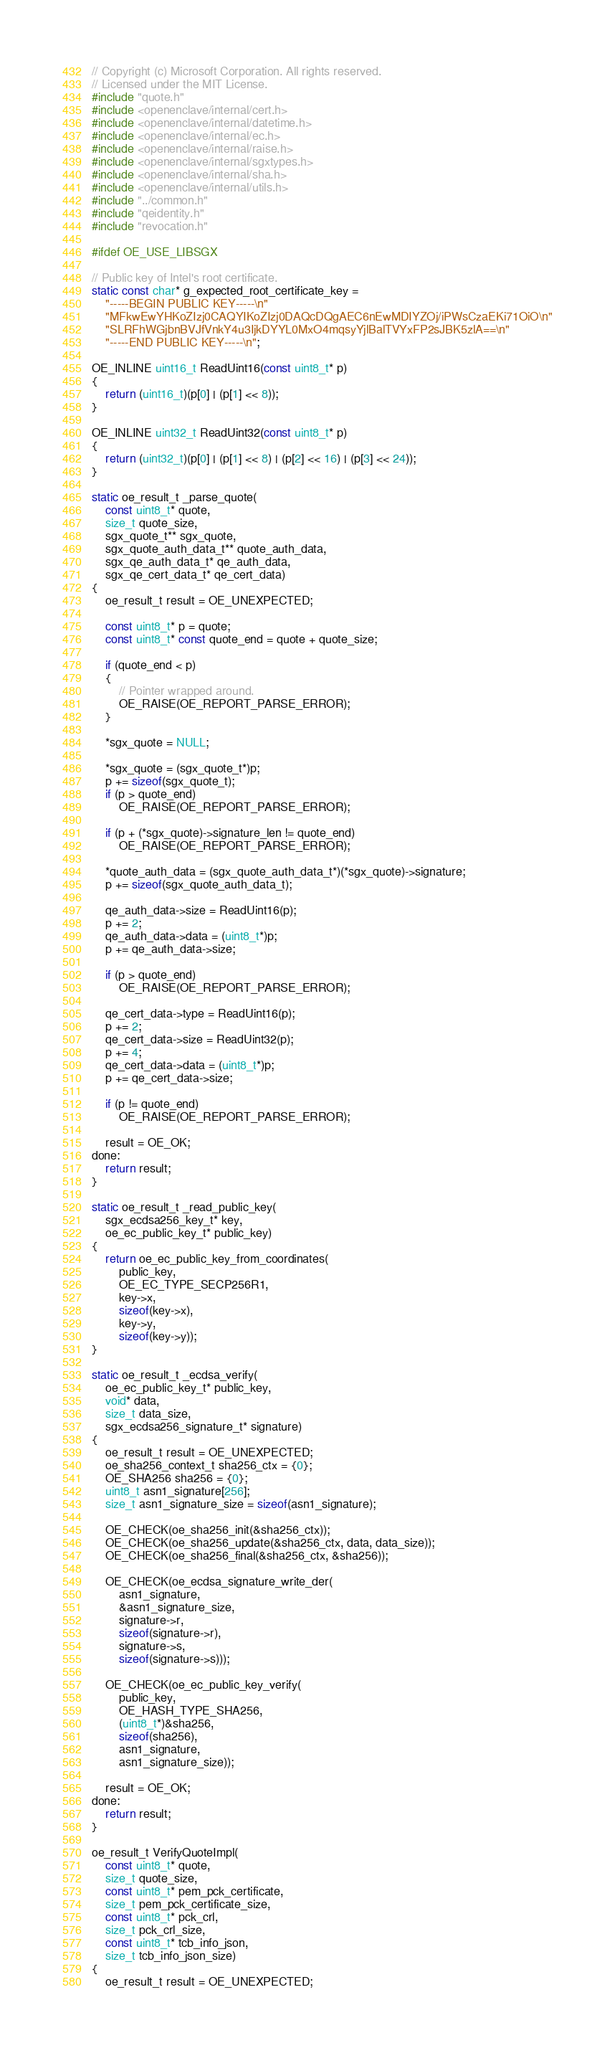<code> <loc_0><loc_0><loc_500><loc_500><_C_>// Copyright (c) Microsoft Corporation. All rights reserved.
// Licensed under the MIT License.
#include "quote.h"
#include <openenclave/internal/cert.h>
#include <openenclave/internal/datetime.h>
#include <openenclave/internal/ec.h>
#include <openenclave/internal/raise.h>
#include <openenclave/internal/sgxtypes.h>
#include <openenclave/internal/sha.h>
#include <openenclave/internal/utils.h>
#include "../common.h"
#include "qeidentity.h"
#include "revocation.h"

#ifdef OE_USE_LIBSGX

// Public key of Intel's root certificate.
static const char* g_expected_root_certificate_key =
    "-----BEGIN PUBLIC KEY-----\n"
    "MFkwEwYHKoZIzj0CAQYIKoZIzj0DAQcDQgAEC6nEwMDIYZOj/iPWsCzaEKi71OiO\n"
    "SLRFhWGjbnBVJfVnkY4u3IjkDYYL0MxO4mqsyYjlBalTVYxFP2sJBK5zlA==\n"
    "-----END PUBLIC KEY-----\n";

OE_INLINE uint16_t ReadUint16(const uint8_t* p)
{
    return (uint16_t)(p[0] | (p[1] << 8));
}

OE_INLINE uint32_t ReadUint32(const uint8_t* p)
{
    return (uint32_t)(p[0] | (p[1] << 8) | (p[2] << 16) | (p[3] << 24));
}

static oe_result_t _parse_quote(
    const uint8_t* quote,
    size_t quote_size,
    sgx_quote_t** sgx_quote,
    sgx_quote_auth_data_t** quote_auth_data,
    sgx_qe_auth_data_t* qe_auth_data,
    sgx_qe_cert_data_t* qe_cert_data)
{
    oe_result_t result = OE_UNEXPECTED;

    const uint8_t* p = quote;
    const uint8_t* const quote_end = quote + quote_size;

    if (quote_end < p)
    {
        // Pointer wrapped around.
        OE_RAISE(OE_REPORT_PARSE_ERROR);
    }

    *sgx_quote = NULL;

    *sgx_quote = (sgx_quote_t*)p;
    p += sizeof(sgx_quote_t);
    if (p > quote_end)
        OE_RAISE(OE_REPORT_PARSE_ERROR);

    if (p + (*sgx_quote)->signature_len != quote_end)
        OE_RAISE(OE_REPORT_PARSE_ERROR);

    *quote_auth_data = (sgx_quote_auth_data_t*)(*sgx_quote)->signature;
    p += sizeof(sgx_quote_auth_data_t);

    qe_auth_data->size = ReadUint16(p);
    p += 2;
    qe_auth_data->data = (uint8_t*)p;
    p += qe_auth_data->size;

    if (p > quote_end)
        OE_RAISE(OE_REPORT_PARSE_ERROR);

    qe_cert_data->type = ReadUint16(p);
    p += 2;
    qe_cert_data->size = ReadUint32(p);
    p += 4;
    qe_cert_data->data = (uint8_t*)p;
    p += qe_cert_data->size;

    if (p != quote_end)
        OE_RAISE(OE_REPORT_PARSE_ERROR);

    result = OE_OK;
done:
    return result;
}

static oe_result_t _read_public_key(
    sgx_ecdsa256_key_t* key,
    oe_ec_public_key_t* public_key)
{
    return oe_ec_public_key_from_coordinates(
        public_key,
        OE_EC_TYPE_SECP256R1,
        key->x,
        sizeof(key->x),
        key->y,
        sizeof(key->y));
}

static oe_result_t _ecdsa_verify(
    oe_ec_public_key_t* public_key,
    void* data,
    size_t data_size,
    sgx_ecdsa256_signature_t* signature)
{
    oe_result_t result = OE_UNEXPECTED;
    oe_sha256_context_t sha256_ctx = {0};
    OE_SHA256 sha256 = {0};
    uint8_t asn1_signature[256];
    size_t asn1_signature_size = sizeof(asn1_signature);

    OE_CHECK(oe_sha256_init(&sha256_ctx));
    OE_CHECK(oe_sha256_update(&sha256_ctx, data, data_size));
    OE_CHECK(oe_sha256_final(&sha256_ctx, &sha256));

    OE_CHECK(oe_ecdsa_signature_write_der(
        asn1_signature,
        &asn1_signature_size,
        signature->r,
        sizeof(signature->r),
        signature->s,
        sizeof(signature->s)));

    OE_CHECK(oe_ec_public_key_verify(
        public_key,
        OE_HASH_TYPE_SHA256,
        (uint8_t*)&sha256,
        sizeof(sha256),
        asn1_signature,
        asn1_signature_size));

    result = OE_OK;
done:
    return result;
}

oe_result_t VerifyQuoteImpl(
    const uint8_t* quote,
    size_t quote_size,
    const uint8_t* pem_pck_certificate,
    size_t pem_pck_certificate_size,
    const uint8_t* pck_crl,
    size_t pck_crl_size,
    const uint8_t* tcb_info_json,
    size_t tcb_info_json_size)
{
    oe_result_t result = OE_UNEXPECTED;</code> 